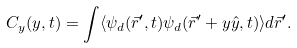Convert formula to latex. <formula><loc_0><loc_0><loc_500><loc_500>C _ { y } ( y , t ) = \int \langle \psi _ { d } ( \vec { r } ^ { \prime } , t ) \psi _ { d } ( \vec { r } ^ { \prime } + y \hat { y } , t ) \rangle d \vec { r } ^ { \prime } .</formula> 